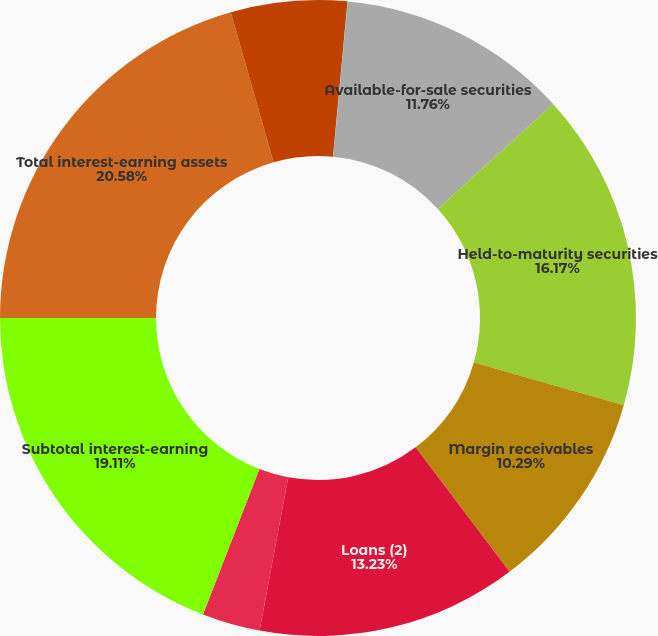Convert chart to OTSL. <chart><loc_0><loc_0><loc_500><loc_500><pie_chart><fcel>Cash and equivalents<fcel>Cash required to be segregated<fcel>Available-for-sale securities<fcel>Held-to-maturity securities<fcel>Margin receivables<fcel>Loans (2)<fcel>Broker-related receivables and<fcel>Subtotal interest-earning<fcel>Total interest-earning assets<fcel>Sweep deposits<nl><fcel>1.48%<fcel>0.01%<fcel>11.76%<fcel>16.17%<fcel>10.29%<fcel>13.23%<fcel>2.95%<fcel>19.11%<fcel>20.58%<fcel>4.42%<nl></chart> 